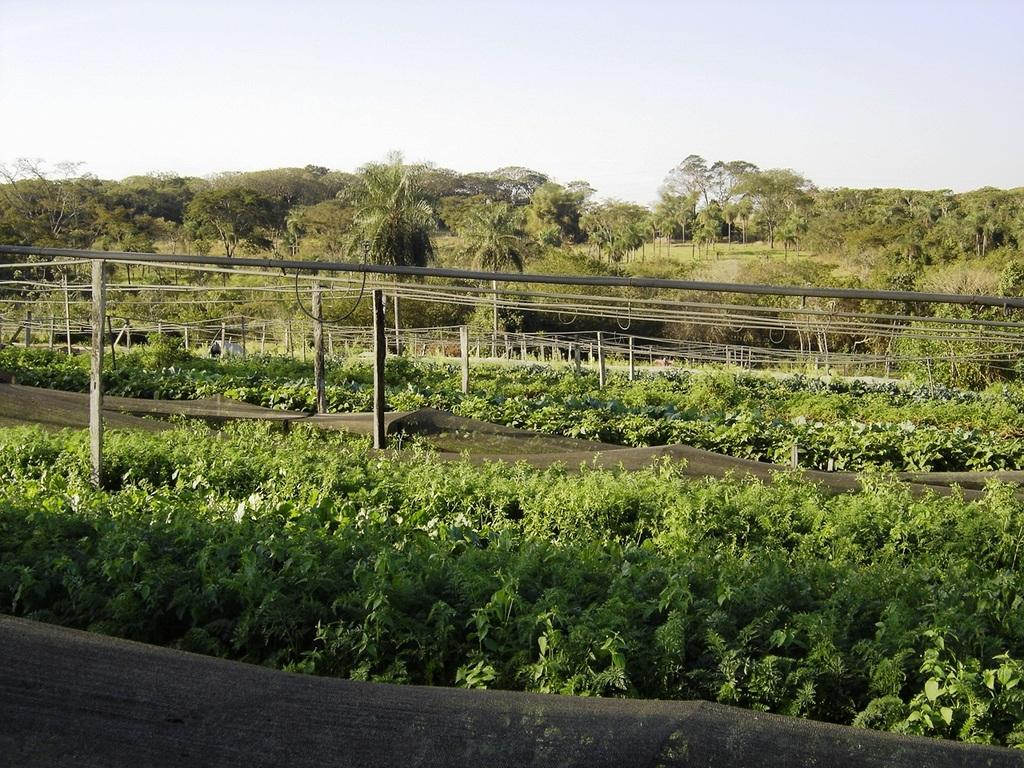What type of view is shown in the image? The image is an outside view. What can be seen in the image besides the sky? There are many plants and trees in the image. What are the poles on the ground used for? The purpose of the poles on the ground is not specified in the image. What is visible at the top of the image? The sky is visible at the top of the image. Can you see any planes flying in the sky in the image? There are no planes visible in the sky in the image. Is there a cobweb hanging from any of the trees in the image? There is no cobweb visible in the image. 